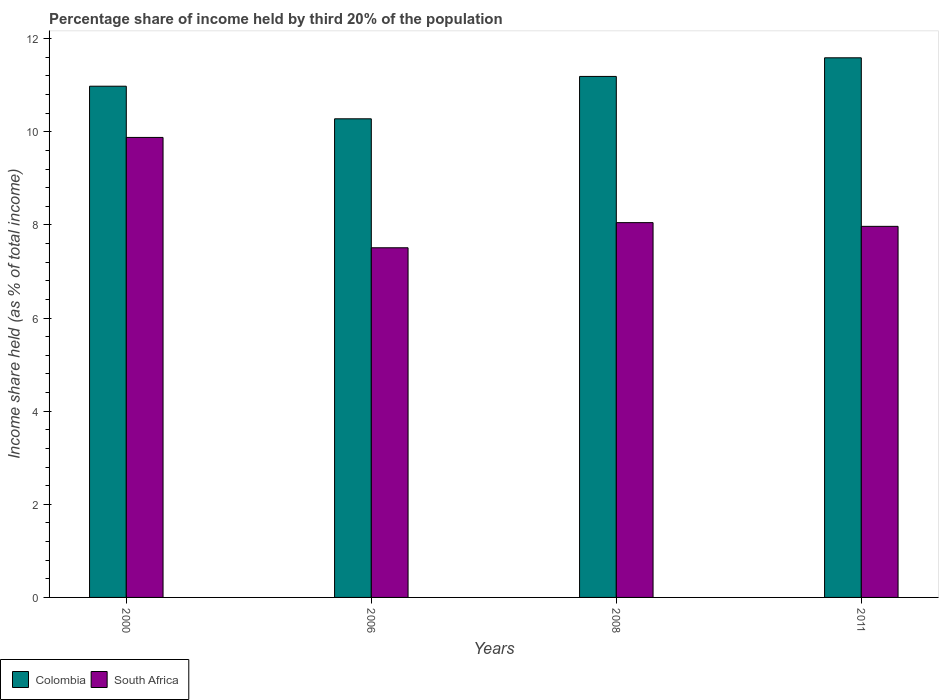Are the number of bars per tick equal to the number of legend labels?
Provide a succinct answer. Yes. How many bars are there on the 2nd tick from the left?
Offer a terse response. 2. How many bars are there on the 2nd tick from the right?
Give a very brief answer. 2. What is the label of the 1st group of bars from the left?
Your response must be concise. 2000. What is the share of income held by third 20% of the population in Colombia in 2006?
Provide a short and direct response. 10.28. Across all years, what is the maximum share of income held by third 20% of the population in South Africa?
Provide a short and direct response. 9.88. Across all years, what is the minimum share of income held by third 20% of the population in Colombia?
Your answer should be very brief. 10.28. In which year was the share of income held by third 20% of the population in South Africa minimum?
Make the answer very short. 2006. What is the total share of income held by third 20% of the population in South Africa in the graph?
Keep it short and to the point. 33.41. What is the difference between the share of income held by third 20% of the population in Colombia in 2000 and that in 2006?
Make the answer very short. 0.7. What is the difference between the share of income held by third 20% of the population in Colombia in 2000 and the share of income held by third 20% of the population in South Africa in 2006?
Keep it short and to the point. 3.47. What is the average share of income held by third 20% of the population in South Africa per year?
Your answer should be very brief. 8.35. In the year 2011, what is the difference between the share of income held by third 20% of the population in South Africa and share of income held by third 20% of the population in Colombia?
Provide a short and direct response. -3.62. What is the ratio of the share of income held by third 20% of the population in Colombia in 2006 to that in 2011?
Keep it short and to the point. 0.89. Is the share of income held by third 20% of the population in Colombia in 2000 less than that in 2006?
Your response must be concise. No. Is the difference between the share of income held by third 20% of the population in South Africa in 2006 and 2011 greater than the difference between the share of income held by third 20% of the population in Colombia in 2006 and 2011?
Offer a very short reply. Yes. What is the difference between the highest and the second highest share of income held by third 20% of the population in Colombia?
Provide a succinct answer. 0.4. What is the difference between the highest and the lowest share of income held by third 20% of the population in South Africa?
Provide a succinct answer. 2.37. In how many years, is the share of income held by third 20% of the population in Colombia greater than the average share of income held by third 20% of the population in Colombia taken over all years?
Your answer should be compact. 2. What does the 2nd bar from the left in 2008 represents?
Provide a short and direct response. South Africa. How many years are there in the graph?
Provide a succinct answer. 4. What is the difference between two consecutive major ticks on the Y-axis?
Your answer should be compact. 2. Are the values on the major ticks of Y-axis written in scientific E-notation?
Provide a succinct answer. No. Does the graph contain any zero values?
Keep it short and to the point. No. Does the graph contain grids?
Give a very brief answer. No. Where does the legend appear in the graph?
Offer a terse response. Bottom left. How many legend labels are there?
Offer a terse response. 2. What is the title of the graph?
Your answer should be compact. Percentage share of income held by third 20% of the population. Does "Saudi Arabia" appear as one of the legend labels in the graph?
Give a very brief answer. No. What is the label or title of the Y-axis?
Ensure brevity in your answer.  Income share held (as % of total income). What is the Income share held (as % of total income) of Colombia in 2000?
Keep it short and to the point. 10.98. What is the Income share held (as % of total income) in South Africa in 2000?
Provide a succinct answer. 9.88. What is the Income share held (as % of total income) of Colombia in 2006?
Offer a terse response. 10.28. What is the Income share held (as % of total income) in South Africa in 2006?
Your answer should be compact. 7.51. What is the Income share held (as % of total income) of Colombia in 2008?
Make the answer very short. 11.19. What is the Income share held (as % of total income) in South Africa in 2008?
Your response must be concise. 8.05. What is the Income share held (as % of total income) in Colombia in 2011?
Provide a succinct answer. 11.59. What is the Income share held (as % of total income) of South Africa in 2011?
Provide a short and direct response. 7.97. Across all years, what is the maximum Income share held (as % of total income) in Colombia?
Keep it short and to the point. 11.59. Across all years, what is the maximum Income share held (as % of total income) in South Africa?
Keep it short and to the point. 9.88. Across all years, what is the minimum Income share held (as % of total income) in Colombia?
Give a very brief answer. 10.28. Across all years, what is the minimum Income share held (as % of total income) in South Africa?
Your answer should be compact. 7.51. What is the total Income share held (as % of total income) in Colombia in the graph?
Your response must be concise. 44.04. What is the total Income share held (as % of total income) of South Africa in the graph?
Ensure brevity in your answer.  33.41. What is the difference between the Income share held (as % of total income) of South Africa in 2000 and that in 2006?
Offer a very short reply. 2.37. What is the difference between the Income share held (as % of total income) in Colombia in 2000 and that in 2008?
Provide a short and direct response. -0.21. What is the difference between the Income share held (as % of total income) of South Africa in 2000 and that in 2008?
Make the answer very short. 1.83. What is the difference between the Income share held (as % of total income) in Colombia in 2000 and that in 2011?
Offer a very short reply. -0.61. What is the difference between the Income share held (as % of total income) of South Africa in 2000 and that in 2011?
Provide a succinct answer. 1.91. What is the difference between the Income share held (as % of total income) of Colombia in 2006 and that in 2008?
Your answer should be compact. -0.91. What is the difference between the Income share held (as % of total income) of South Africa in 2006 and that in 2008?
Offer a terse response. -0.54. What is the difference between the Income share held (as % of total income) in Colombia in 2006 and that in 2011?
Give a very brief answer. -1.31. What is the difference between the Income share held (as % of total income) of South Africa in 2006 and that in 2011?
Offer a very short reply. -0.46. What is the difference between the Income share held (as % of total income) in South Africa in 2008 and that in 2011?
Ensure brevity in your answer.  0.08. What is the difference between the Income share held (as % of total income) in Colombia in 2000 and the Income share held (as % of total income) in South Africa in 2006?
Keep it short and to the point. 3.47. What is the difference between the Income share held (as % of total income) in Colombia in 2000 and the Income share held (as % of total income) in South Africa in 2008?
Your answer should be compact. 2.93. What is the difference between the Income share held (as % of total income) of Colombia in 2000 and the Income share held (as % of total income) of South Africa in 2011?
Your answer should be compact. 3.01. What is the difference between the Income share held (as % of total income) in Colombia in 2006 and the Income share held (as % of total income) in South Africa in 2008?
Ensure brevity in your answer.  2.23. What is the difference between the Income share held (as % of total income) in Colombia in 2006 and the Income share held (as % of total income) in South Africa in 2011?
Your answer should be compact. 2.31. What is the difference between the Income share held (as % of total income) in Colombia in 2008 and the Income share held (as % of total income) in South Africa in 2011?
Provide a short and direct response. 3.22. What is the average Income share held (as % of total income) in Colombia per year?
Ensure brevity in your answer.  11.01. What is the average Income share held (as % of total income) in South Africa per year?
Provide a short and direct response. 8.35. In the year 2000, what is the difference between the Income share held (as % of total income) in Colombia and Income share held (as % of total income) in South Africa?
Offer a very short reply. 1.1. In the year 2006, what is the difference between the Income share held (as % of total income) in Colombia and Income share held (as % of total income) in South Africa?
Give a very brief answer. 2.77. In the year 2008, what is the difference between the Income share held (as % of total income) in Colombia and Income share held (as % of total income) in South Africa?
Provide a short and direct response. 3.14. In the year 2011, what is the difference between the Income share held (as % of total income) of Colombia and Income share held (as % of total income) of South Africa?
Give a very brief answer. 3.62. What is the ratio of the Income share held (as % of total income) of Colombia in 2000 to that in 2006?
Provide a succinct answer. 1.07. What is the ratio of the Income share held (as % of total income) in South Africa in 2000 to that in 2006?
Offer a very short reply. 1.32. What is the ratio of the Income share held (as % of total income) in Colombia in 2000 to that in 2008?
Give a very brief answer. 0.98. What is the ratio of the Income share held (as % of total income) of South Africa in 2000 to that in 2008?
Your response must be concise. 1.23. What is the ratio of the Income share held (as % of total income) in South Africa in 2000 to that in 2011?
Your response must be concise. 1.24. What is the ratio of the Income share held (as % of total income) of Colombia in 2006 to that in 2008?
Offer a very short reply. 0.92. What is the ratio of the Income share held (as % of total income) in South Africa in 2006 to that in 2008?
Offer a terse response. 0.93. What is the ratio of the Income share held (as % of total income) of Colombia in 2006 to that in 2011?
Give a very brief answer. 0.89. What is the ratio of the Income share held (as % of total income) of South Africa in 2006 to that in 2011?
Keep it short and to the point. 0.94. What is the ratio of the Income share held (as % of total income) of Colombia in 2008 to that in 2011?
Make the answer very short. 0.97. What is the difference between the highest and the second highest Income share held (as % of total income) of Colombia?
Make the answer very short. 0.4. What is the difference between the highest and the second highest Income share held (as % of total income) in South Africa?
Your response must be concise. 1.83. What is the difference between the highest and the lowest Income share held (as % of total income) in Colombia?
Give a very brief answer. 1.31. What is the difference between the highest and the lowest Income share held (as % of total income) of South Africa?
Provide a short and direct response. 2.37. 